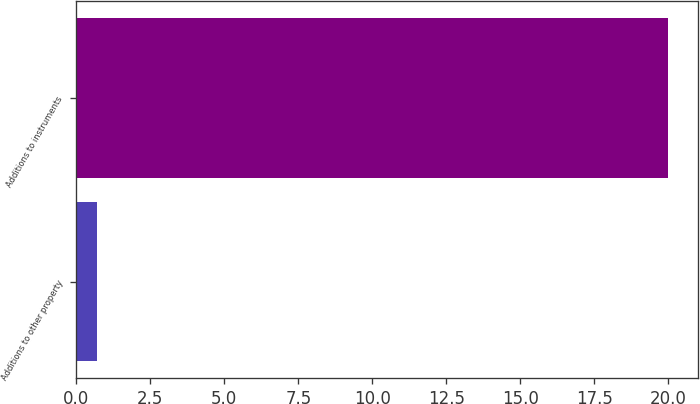<chart> <loc_0><loc_0><loc_500><loc_500><bar_chart><fcel>Additions to other property<fcel>Additions to instruments<nl><fcel>0.7<fcel>20<nl></chart> 